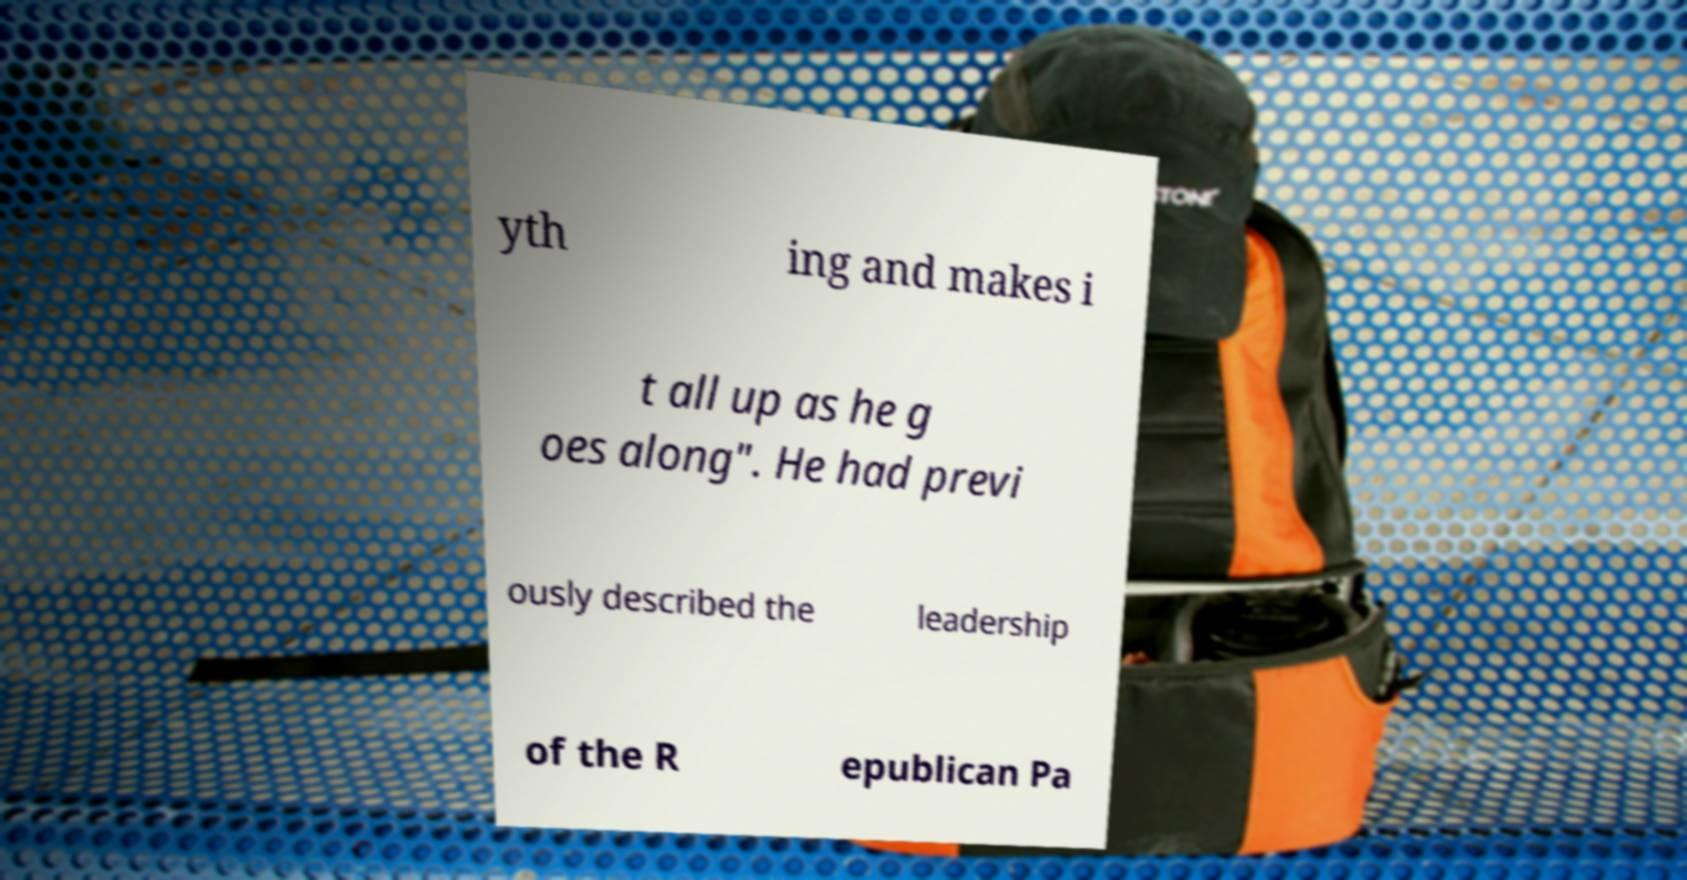Can you read and provide the text displayed in the image?This photo seems to have some interesting text. Can you extract and type it out for me? yth ing and makes i t all up as he g oes along". He had previ ously described the leadership of the R epublican Pa 